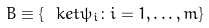Convert formula to latex. <formula><loc_0><loc_0><loc_500><loc_500>B \equiv \{ \ k e t { \psi _ { i } } \colon i = 1 , \dots , m \}</formula> 